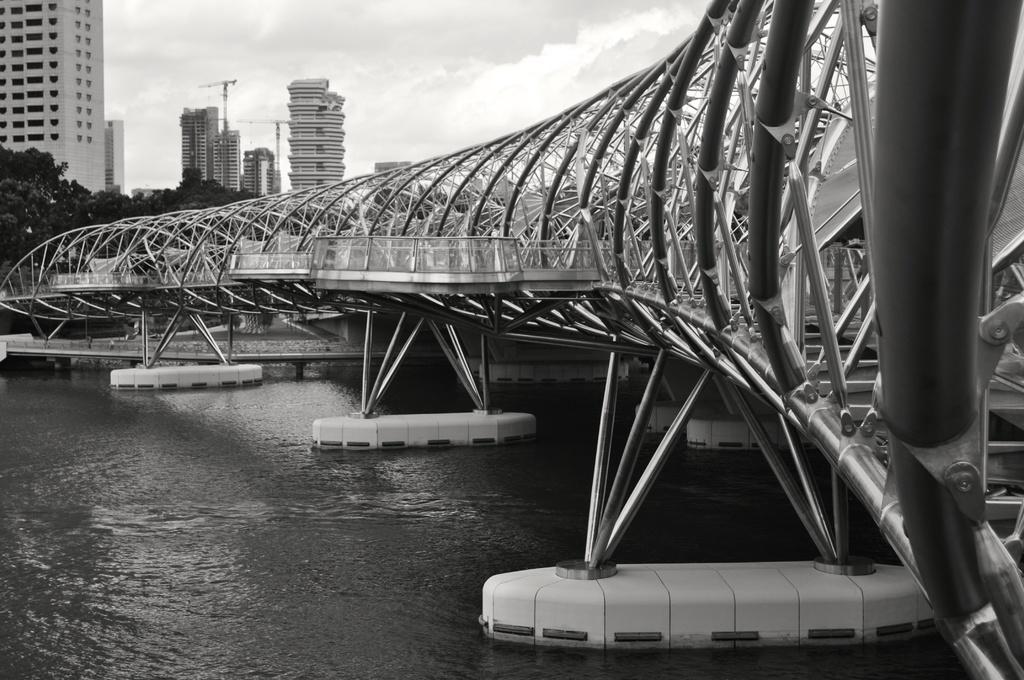Can you describe this image briefly? Here there is water, these are buildings and trees, this is iron structure, this is sky. 